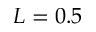<formula> <loc_0><loc_0><loc_500><loc_500>L = 0 . 5</formula> 